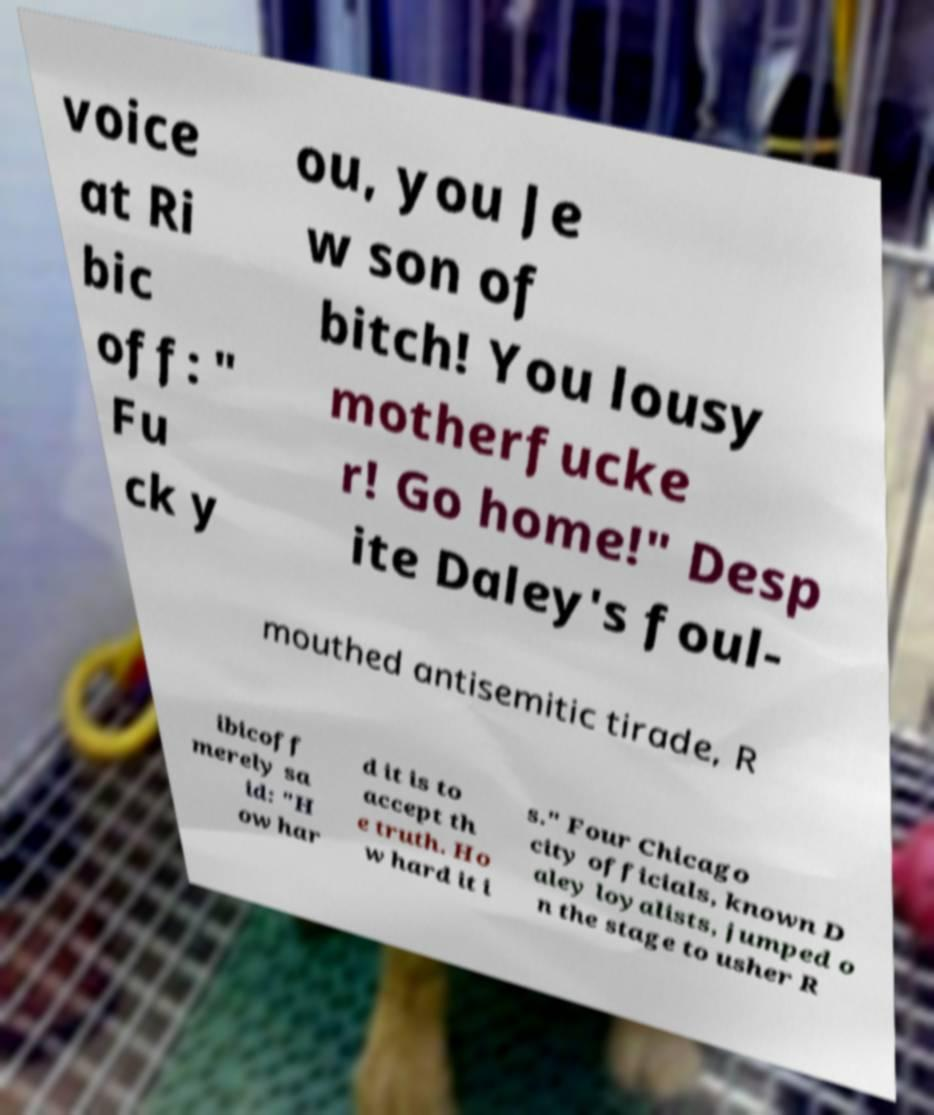Can you read and provide the text displayed in the image?This photo seems to have some interesting text. Can you extract and type it out for me? voice at Ri bic off: " Fu ck y ou, you Je w son of bitch! You lousy motherfucke r! Go home!" Desp ite Daley's foul- mouthed antisemitic tirade, R ibicoff merely sa id: "H ow har d it is to accept th e truth. Ho w hard it i s." Four Chicago city officials, known D aley loyalists, jumped o n the stage to usher R 